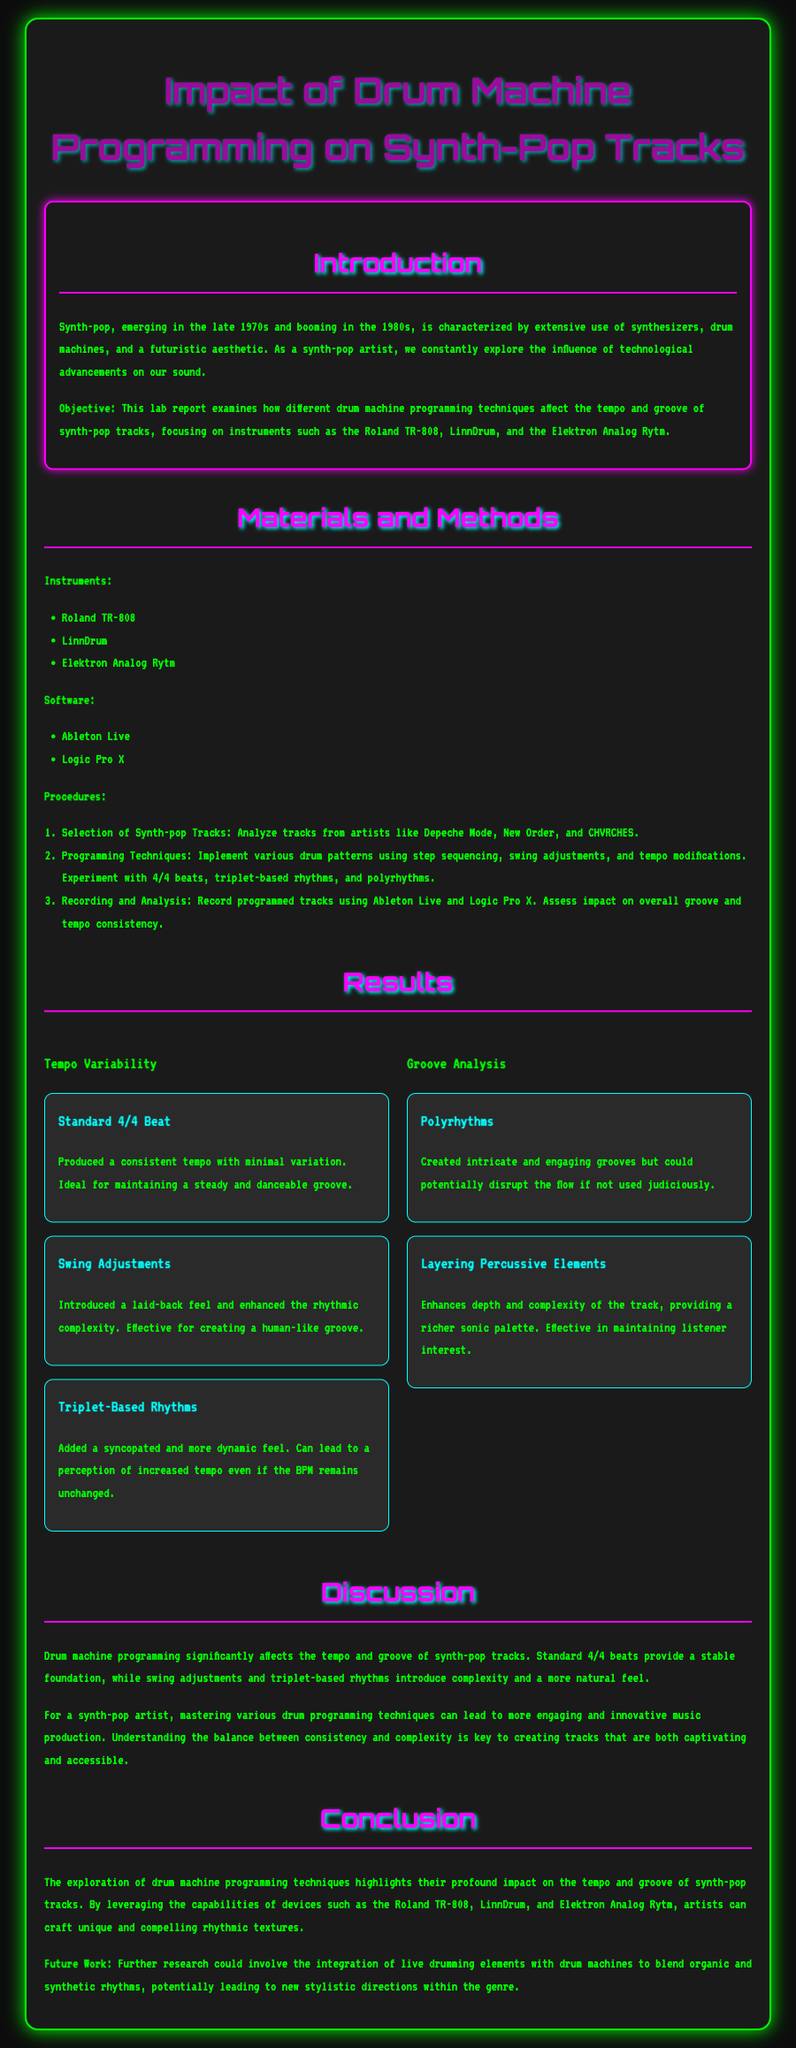What are the three drum machines mentioned? The document lists the Roland TR-808, LinnDrum, and Elektron Analog Rytm as the drum machines used in the study.
Answer: Roland TR-808, LinnDrum, Elektron Analog Rytm What software was used for programming? The document mentions Ableton Live and Logic Pro X as the software utilized during the drum machine programming process.
Answer: Ableton Live, Logic Pro X What is the primary objective of the lab report? The objective outlined in the document is to examine how different drum machine programming techniques affect the tempo and groove of synth-pop tracks.
Answer: Examine drum machine programming techniques' effects Which rhythm technique created a laid-back feel? The document states that swing adjustments introduced a laid-back feel and enhanced rhythmic complexity.
Answer: Swing adjustments How does the document describe the tempo produced by a standard 4/4 beat? It states that a standard 4/4 beat produced a consistent tempo with minimal variation.
Answer: Consistent tempo with minimal variation What future work does the report suggest? The document suggests exploring the integration of live drumming elements with drum machines for blending organic and synthetic rhythms.
Answer: Integration of live drumming elements What is the impact of polyrhythms according to the report? The document highlights that polyrhythms create intricate grooves but can disrupt flow if not used judiciously.
Answer: Intricate grooves; potential flow disruption Which aspect does the discussion primarily focus on? The discussion emphasizes the significant impact of drum machine programming on tempo and groove in synth-pop tracks.
Answer: Impact of drum machine programming 